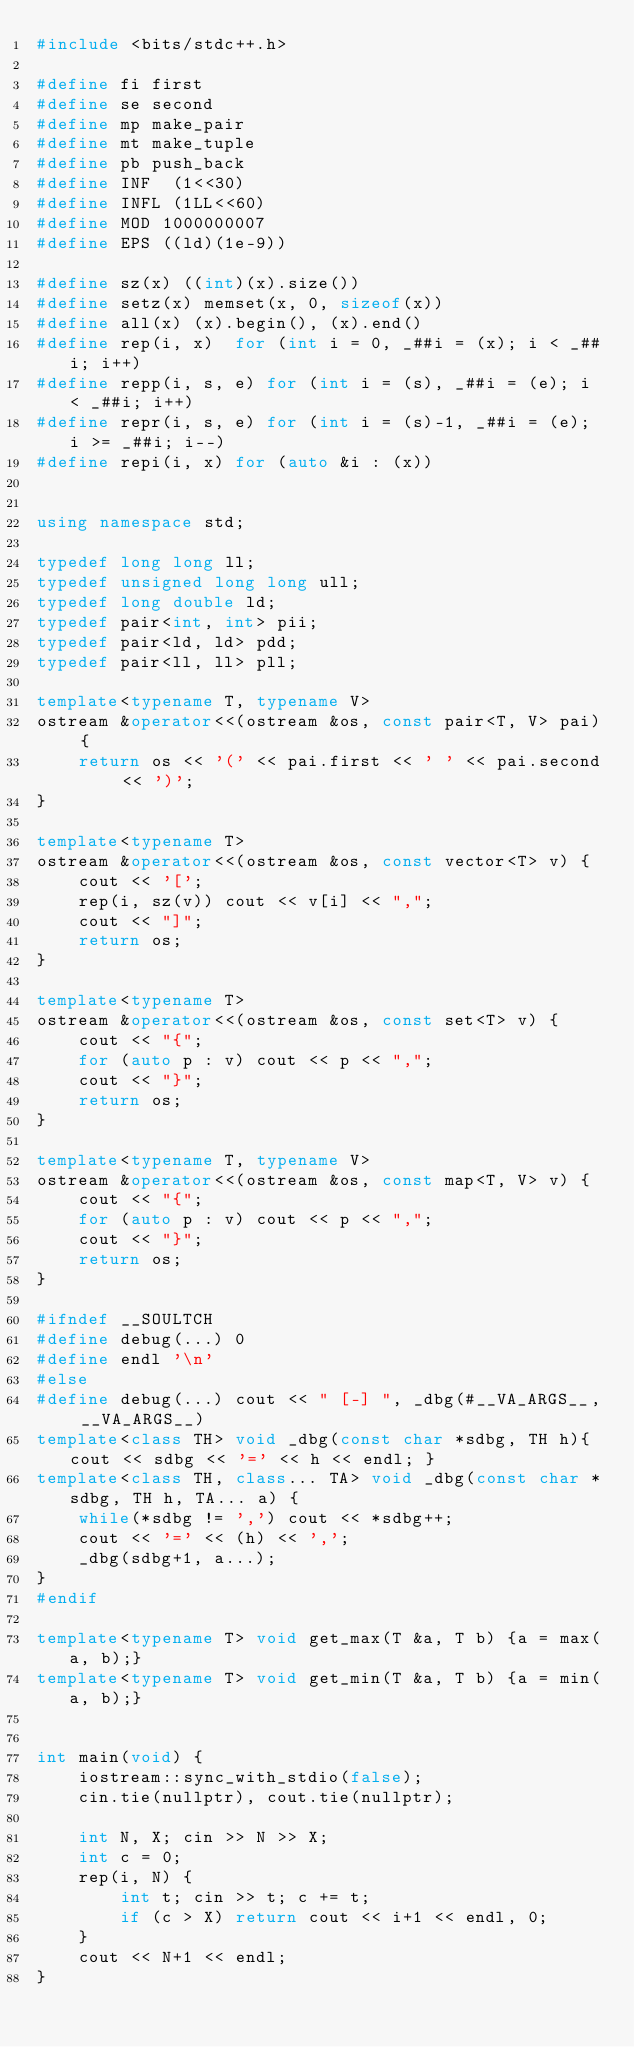Convert code to text. <code><loc_0><loc_0><loc_500><loc_500><_C++_>#include <bits/stdc++.h>

#define fi first
#define se second
#define mp make_pair
#define mt make_tuple
#define pb push_back
#define INF  (1<<30)
#define INFL (1LL<<60)
#define MOD 1000000007
#define EPS ((ld)(1e-9))

#define sz(x) ((int)(x).size())
#define setz(x) memset(x, 0, sizeof(x))
#define all(x) (x).begin(), (x).end()
#define rep(i, x)  for (int i = 0, _##i = (x); i < _##i; i++)
#define repp(i, s, e) for (int i = (s), _##i = (e); i < _##i; i++)
#define repr(i, s, e) for (int i = (s)-1, _##i = (e); i >= _##i; i--)
#define repi(i, x) for (auto &i : (x))


using namespace std;

typedef long long ll;
typedef unsigned long long ull;
typedef long double ld;
typedef pair<int, int> pii;
typedef pair<ld, ld> pdd;
typedef pair<ll, ll> pll;

template<typename T, typename V>
ostream &operator<<(ostream &os, const pair<T, V> pai) { 
    return os << '(' << pai.first << ' ' << pai.second << ')';
}

template<typename T>
ostream &operator<<(ostream &os, const vector<T> v) {
    cout << '[';
    rep(i, sz(v)) cout << v[i] << ",";
    cout << "]";
    return os;
}

template<typename T>
ostream &operator<<(ostream &os, const set<T> v) {
    cout << "{";
    for (auto p : v) cout << p << ",";
    cout << "}";
    return os;
}

template<typename T, typename V>
ostream &operator<<(ostream &os, const map<T, V> v) {
    cout << "{";
    for (auto p : v) cout << p << ",";
    cout << "}";
    return os;
}

#ifndef __SOULTCH
#define debug(...) 0
#define endl '\n'
#else
#define debug(...) cout << " [-] ", _dbg(#__VA_ARGS__, __VA_ARGS__)
template<class TH> void _dbg(const char *sdbg, TH h){ cout << sdbg << '=' << h << endl; }
template<class TH, class... TA> void _dbg(const char *sdbg, TH h, TA... a) {
    while(*sdbg != ',') cout << *sdbg++;
    cout << '=' << (h) << ','; 
    _dbg(sdbg+1, a...);
}
#endif

template<typename T> void get_max(T &a, T b) {a = max(a, b);}
template<typename T> void get_min(T &a, T b) {a = min(a, b);}


int main(void) {
    iostream::sync_with_stdio(false);
    cin.tie(nullptr), cout.tie(nullptr);

    int N, X; cin >> N >> X;
    int c = 0;
    rep(i, N) {
        int t; cin >> t; c += t;
        if (c > X) return cout << i+1 << endl, 0;
    }
    cout << N+1 << endl;
}
</code> 